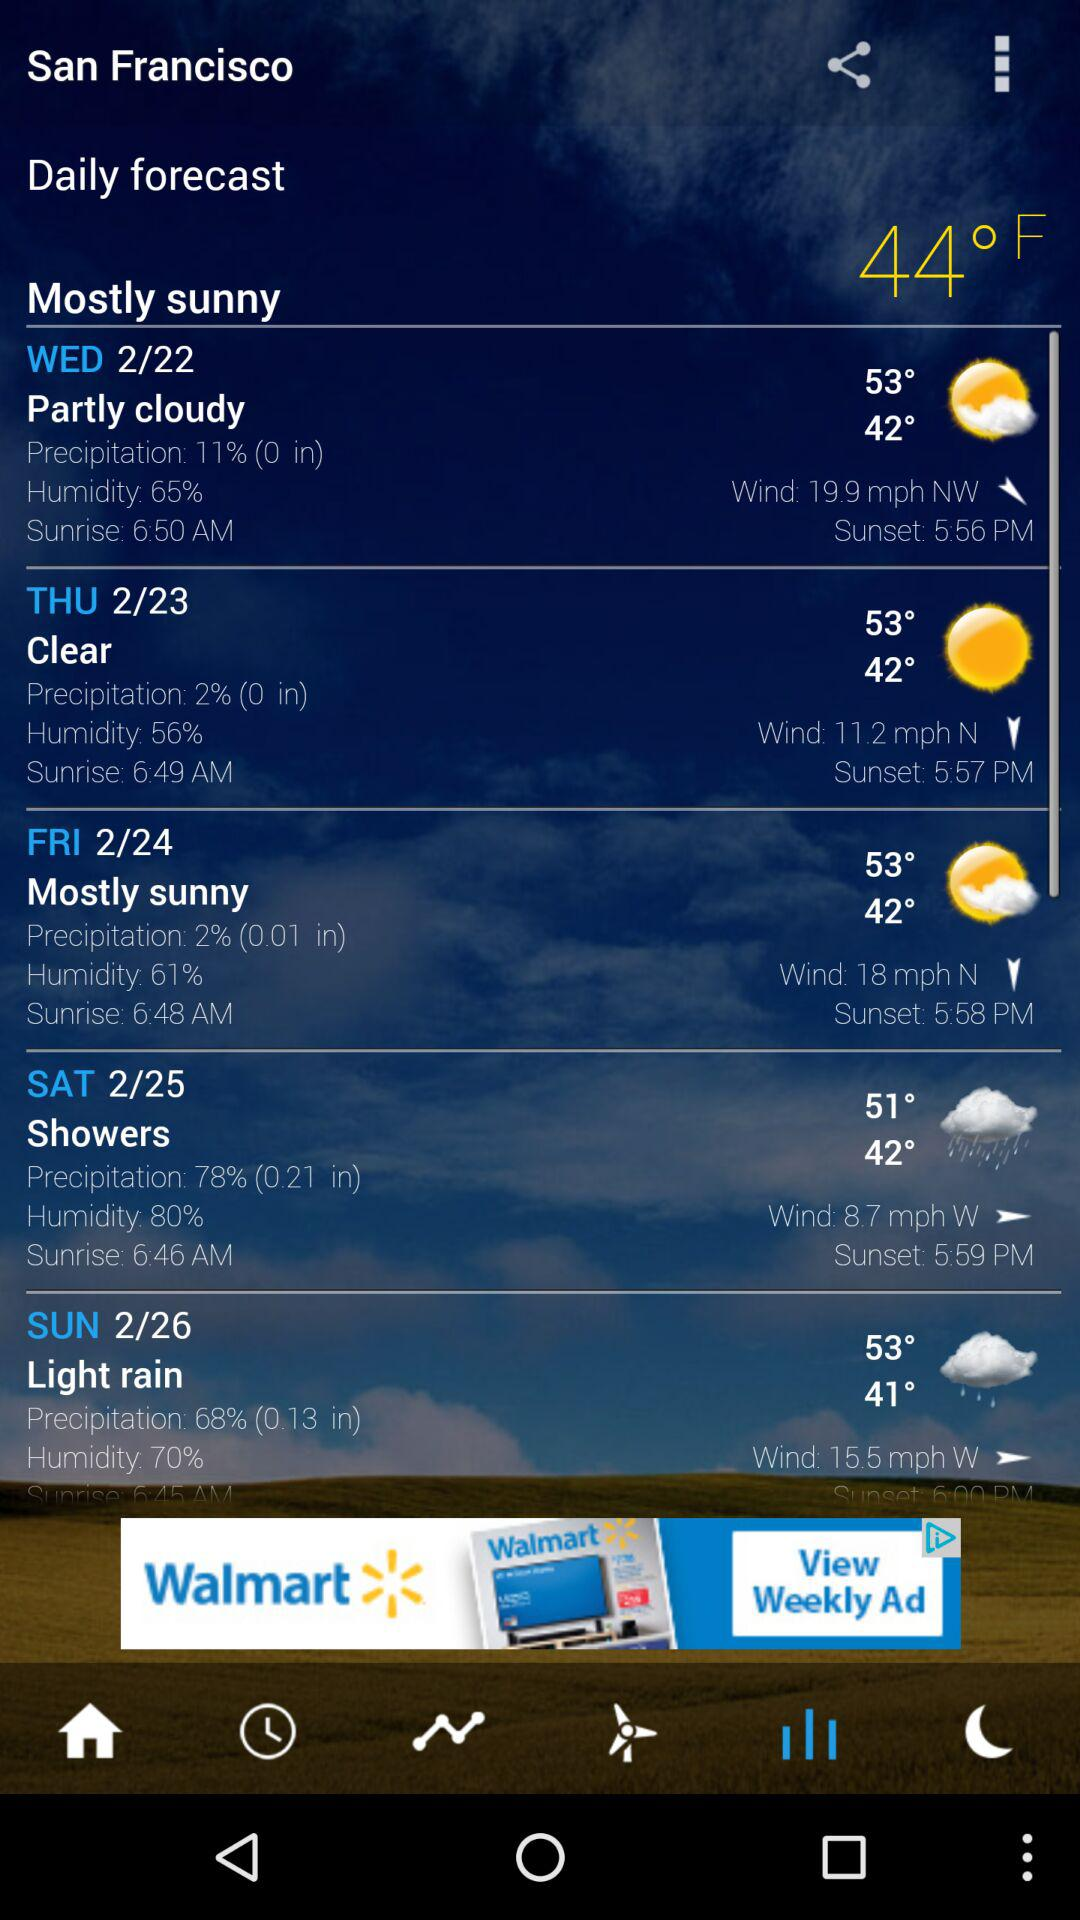What are the daily forecast conditions on Sunday in San Francisco? The daily forecast conditions are light rain, 68% (0.13 in) precipitation, 70% humidity, a maximum temperature of 53 degrees, a minimum temperature of 41 degrees and a wind speed of 15.5 mph W. 